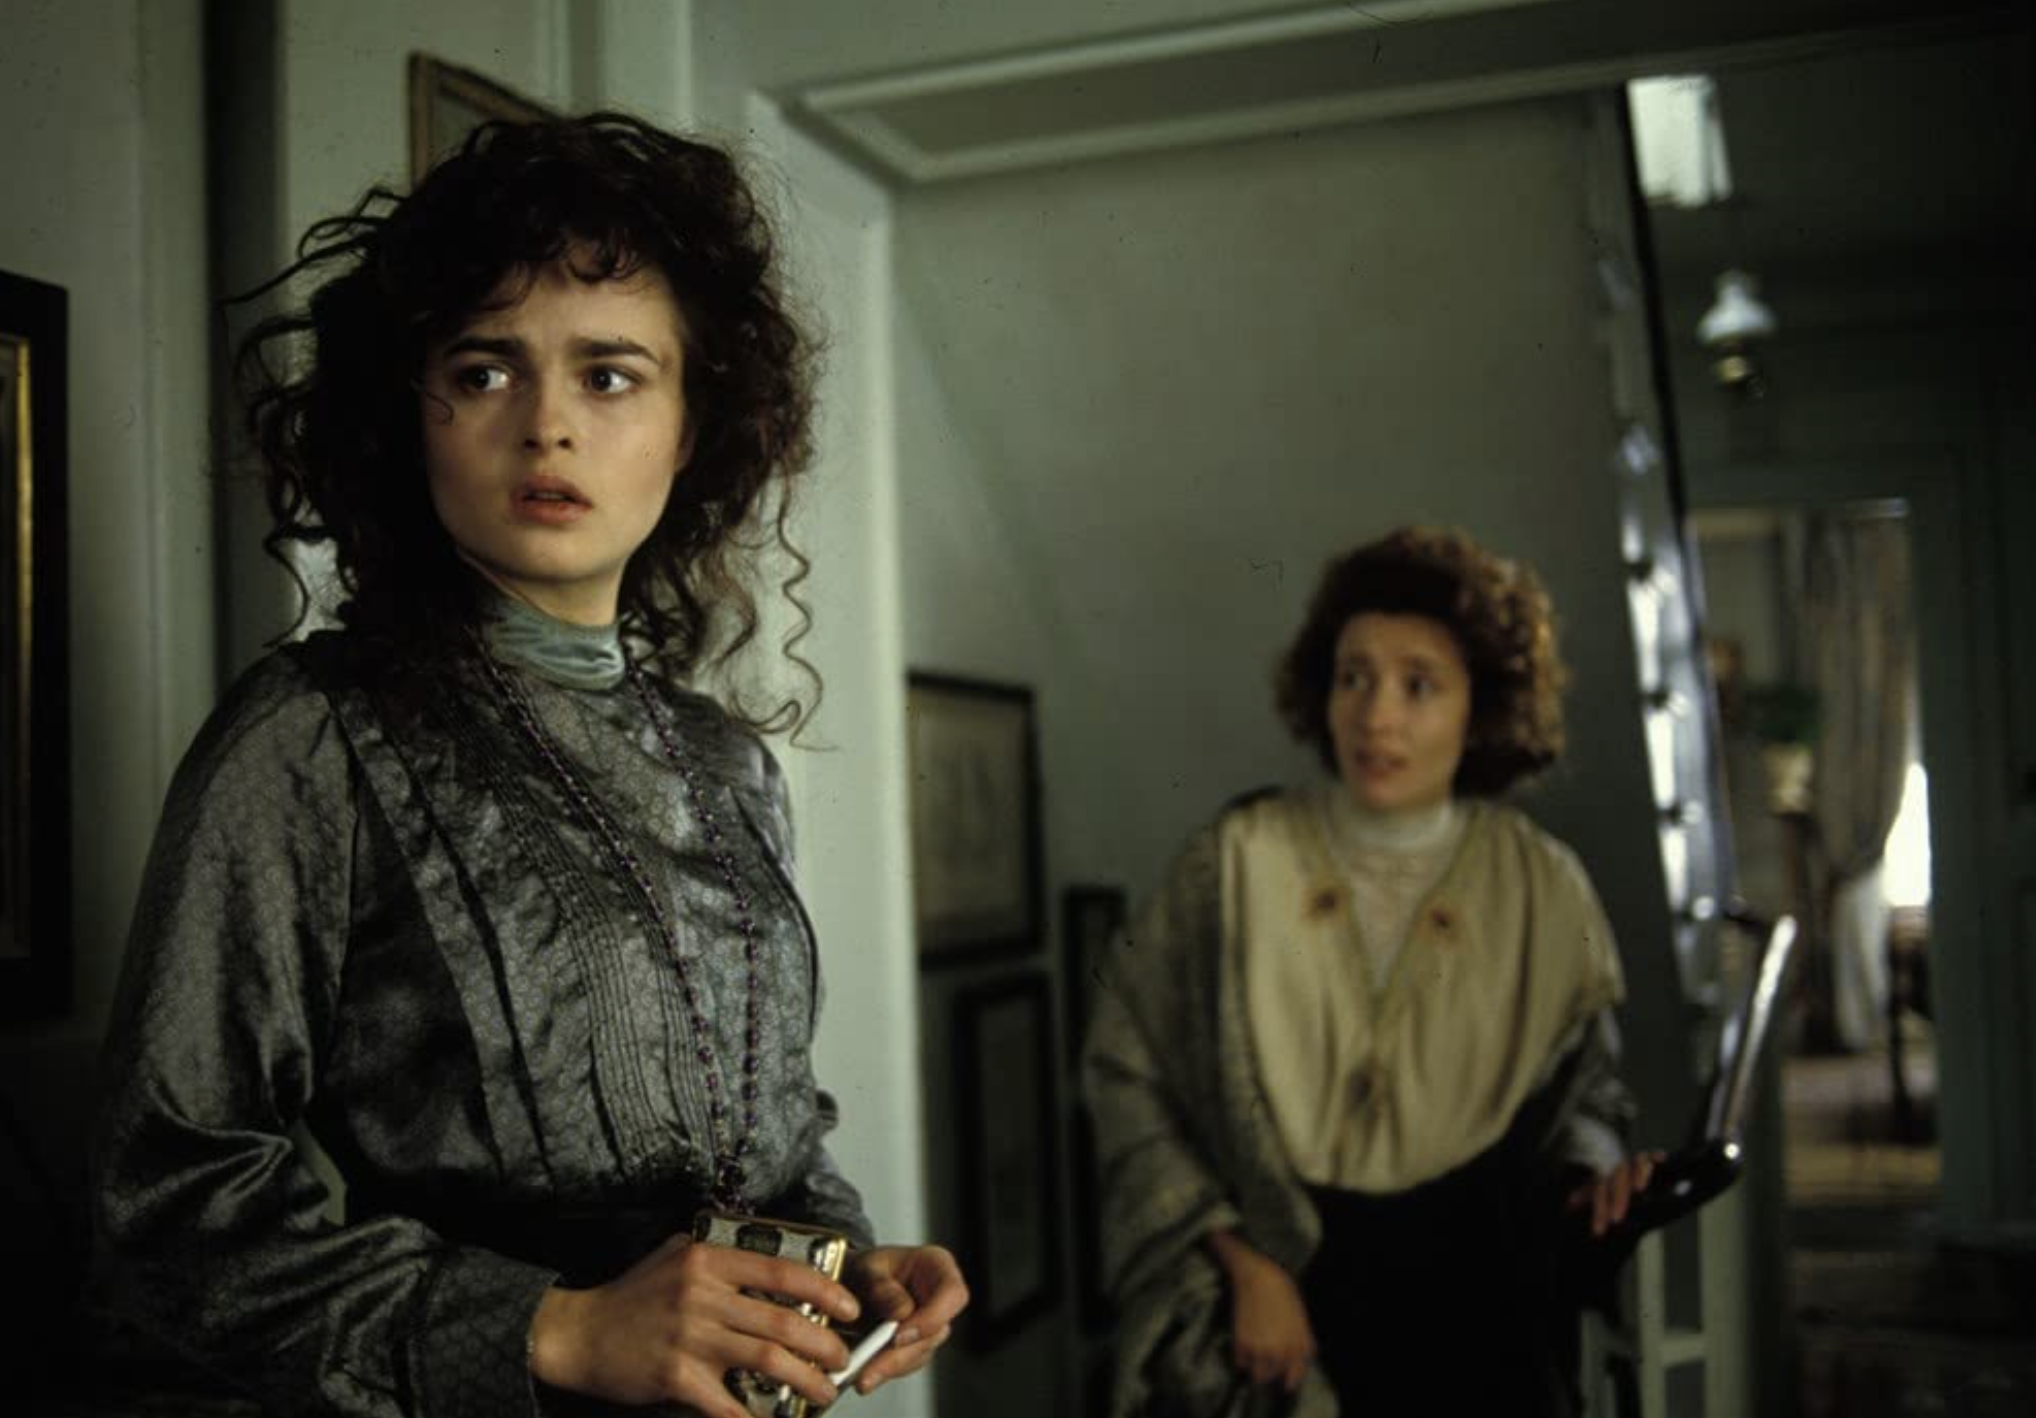Describe the emotions displayed by the central character in this image. Lucy Honeychurch appears to be experiencing worry and perhaps a sense of dread. Her eyes are wide, and her lips are slightly parted, which often indicates alarm or confusion. Her body language, with her hand clutched tightly around an object, further suggests that she is bracing herself for troubling news or an emotional confrontation. Why do you think the director chose this particular setting for this scene? The director likely chose this setting to emphasize the contrast between the serene and orderly room and the emotional turmoil of the characters. The light blue walls and soft lighting create a deceptive calmness, which makes the characters' tension and anxiety stand out even more starkly. It also helps to focus the viewer's attention on the actors’ performances without the distraction of a busy background. 